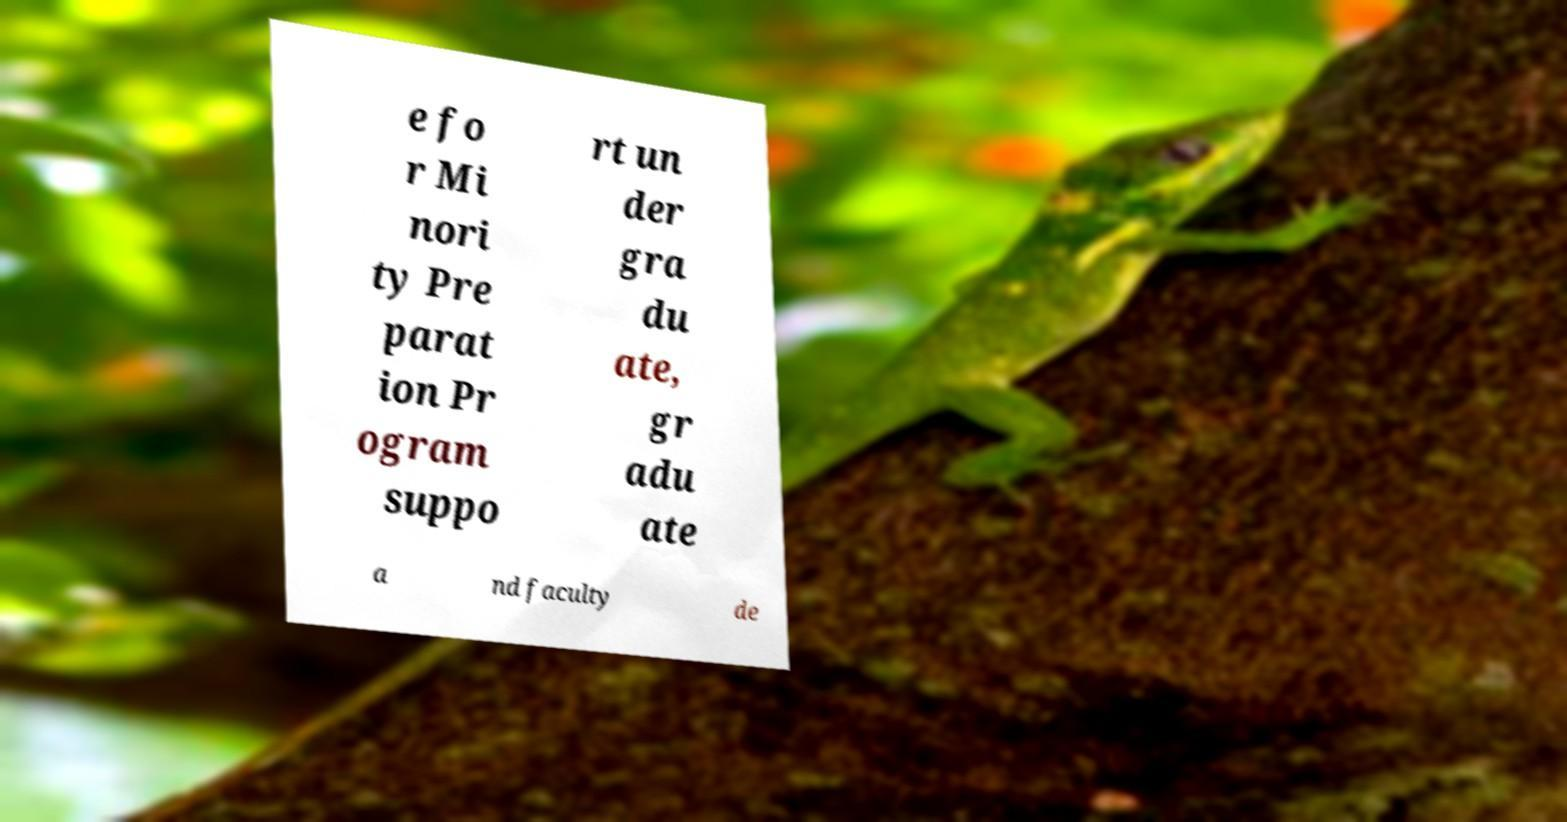Please read and relay the text visible in this image. What does it say? e fo r Mi nori ty Pre parat ion Pr ogram suppo rt un der gra du ate, gr adu ate a nd faculty de 